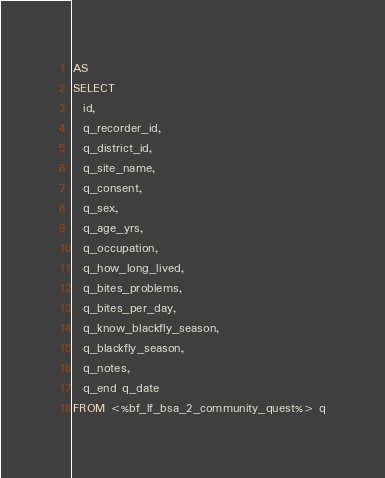Convert code to text. <code><loc_0><loc_0><loc_500><loc_500><_SQL_>AS
SELECT
  id,
  q_recorder_id,
  q_district_id,
  q_site_name,
  q_consent,
  q_sex,
  q_age_yrs,
  q_occupation,
  q_how_long_lived,
  q_bites_problems,
  q_bites_per_day,
  q_know_blackfly_season,
  q_blackfly_season,
  q_notes,
  q_end q_date
FROM <%bf_lf_bsa_2_community_quest%> q
</code> 